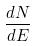<formula> <loc_0><loc_0><loc_500><loc_500>\frac { d N } { d E }</formula> 